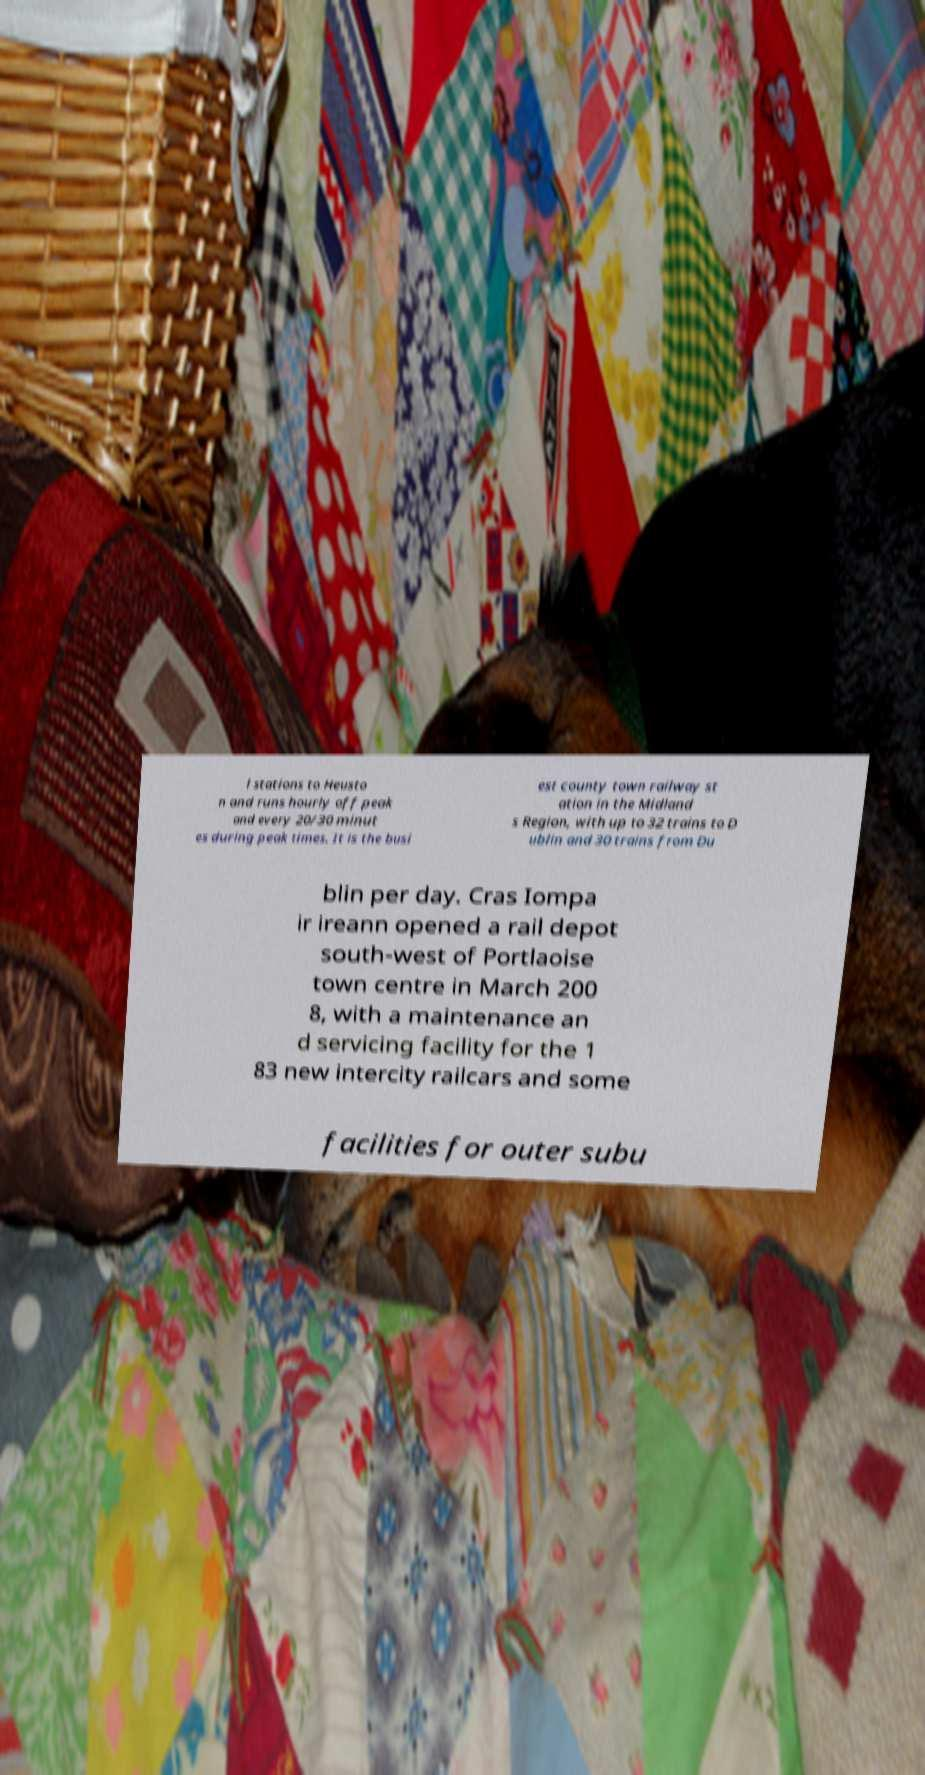There's text embedded in this image that I need extracted. Can you transcribe it verbatim? l stations to Heusto n and runs hourly off peak and every 20/30 minut es during peak times. It is the busi est county town railway st ation in the Midland s Region, with up to 32 trains to D ublin and 30 trains from Du blin per day. Cras Iompa ir ireann opened a rail depot south-west of Portlaoise town centre in March 200 8, with a maintenance an d servicing facility for the 1 83 new intercity railcars and some facilities for outer subu 